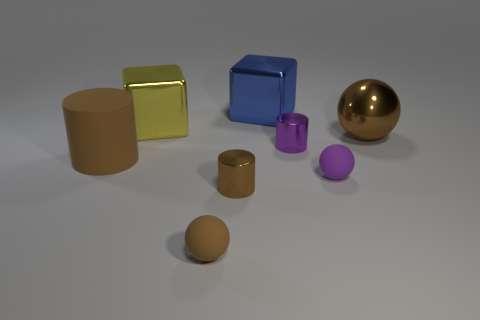What number of brown metal objects are on the left side of the tiny brown matte thing?
Give a very brief answer. 0. Are there an equal number of big brown metal spheres that are in front of the tiny brown cylinder and tiny cyan metallic spheres?
Your answer should be compact. Yes. Does the large brown cylinder have the same material as the small purple sphere?
Provide a short and direct response. Yes. There is a object that is left of the tiny brown matte object and in front of the yellow shiny thing; what size is it?
Keep it short and to the point. Large. How many brown spheres have the same size as the purple cylinder?
Keep it short and to the point. 1. What size is the brown cylinder that is right of the big thing to the left of the yellow metallic block?
Offer a very short reply. Small. Does the brown thing to the right of the small purple matte sphere have the same shape as the small purple object that is in front of the small purple metal object?
Ensure brevity in your answer.  Yes. There is a object that is to the right of the small brown ball and in front of the tiny purple sphere; what is its color?
Your response must be concise. Brown. Is there a small matte ball that has the same color as the large matte object?
Offer a very short reply. Yes. There is a big metallic block behind the large yellow metallic block; what is its color?
Give a very brief answer. Blue. 